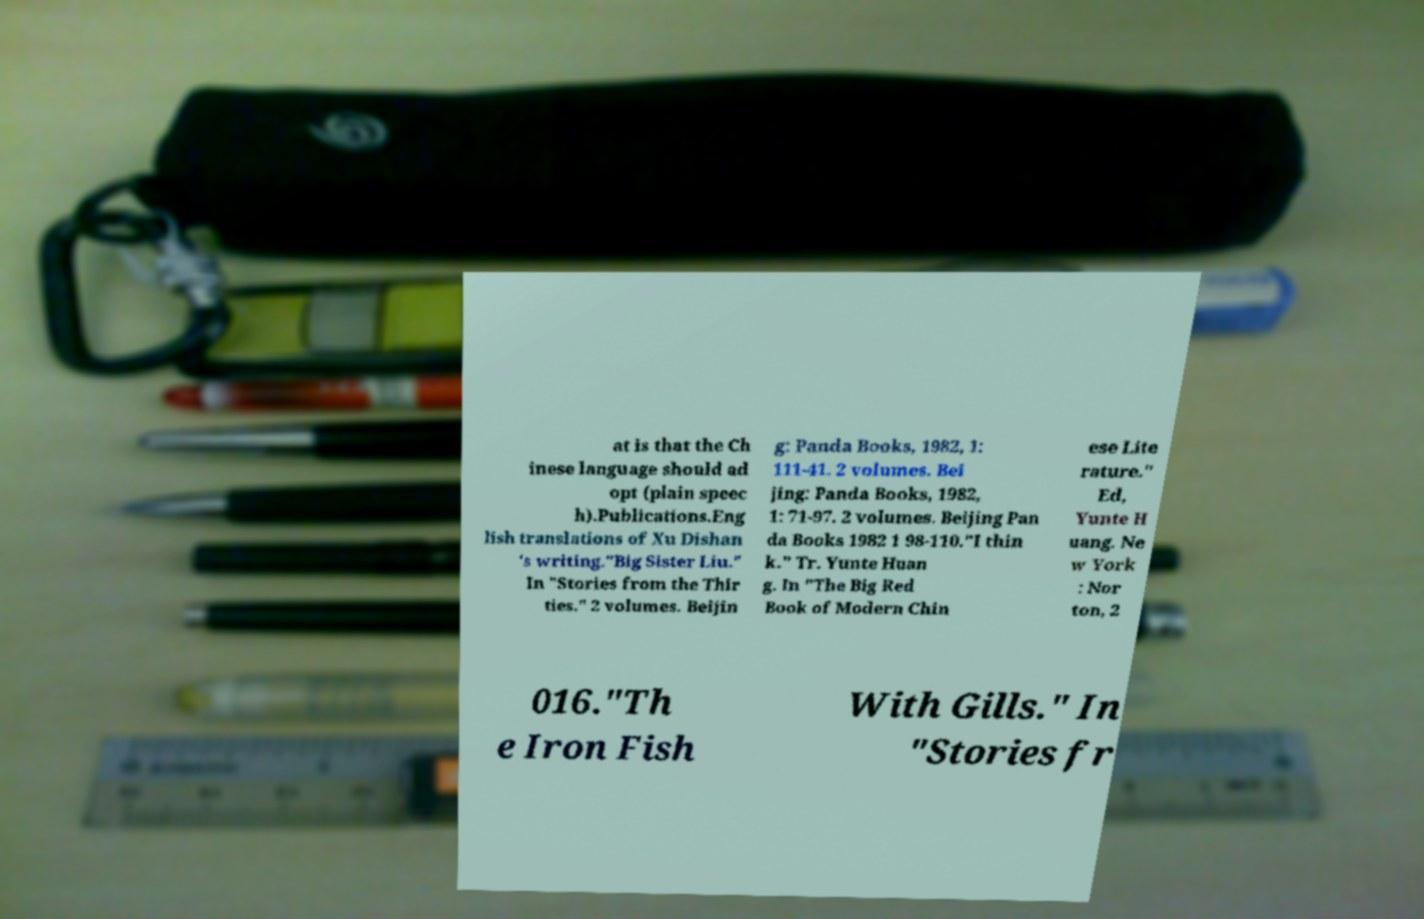There's text embedded in this image that I need extracted. Can you transcribe it verbatim? at is that the Ch inese language should ad opt (plain speec h).Publications.Eng lish translations of Xu Dishan 's writing."Big Sister Liu." In "Stories from the Thir ties." 2 volumes. Beijin g: Panda Books, 1982, 1: 111-41. 2 volumes. Bei jing: Panda Books, 1982, 1: 71-97. 2 volumes. Beijing Pan da Books 1982 1 98-110."I thin k." Tr. Yunte Huan g. In "The Big Red Book of Modern Chin ese Lite rature." Ed, Yunte H uang. Ne w York : Nor ton, 2 016."Th e Iron Fish With Gills." In "Stories fr 